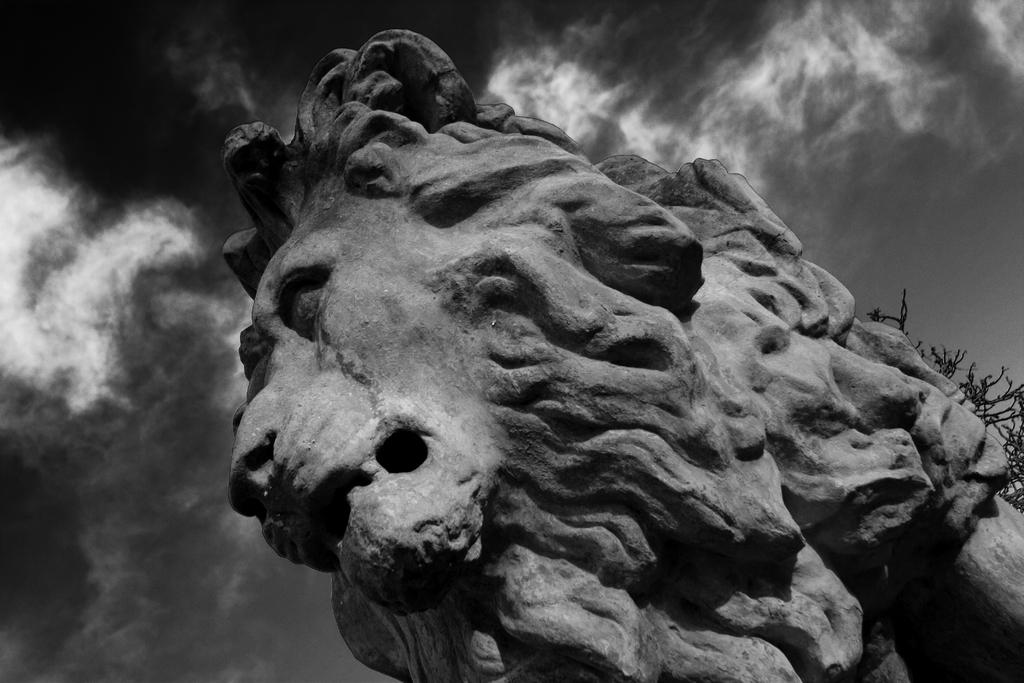What is the main subject in the image? There is a statue in the image. Can you describe the sky in the background? The sky in the background has a white and gray color. What type of instrument is the bee playing in the image? There is no bee or instrument present in the image. 